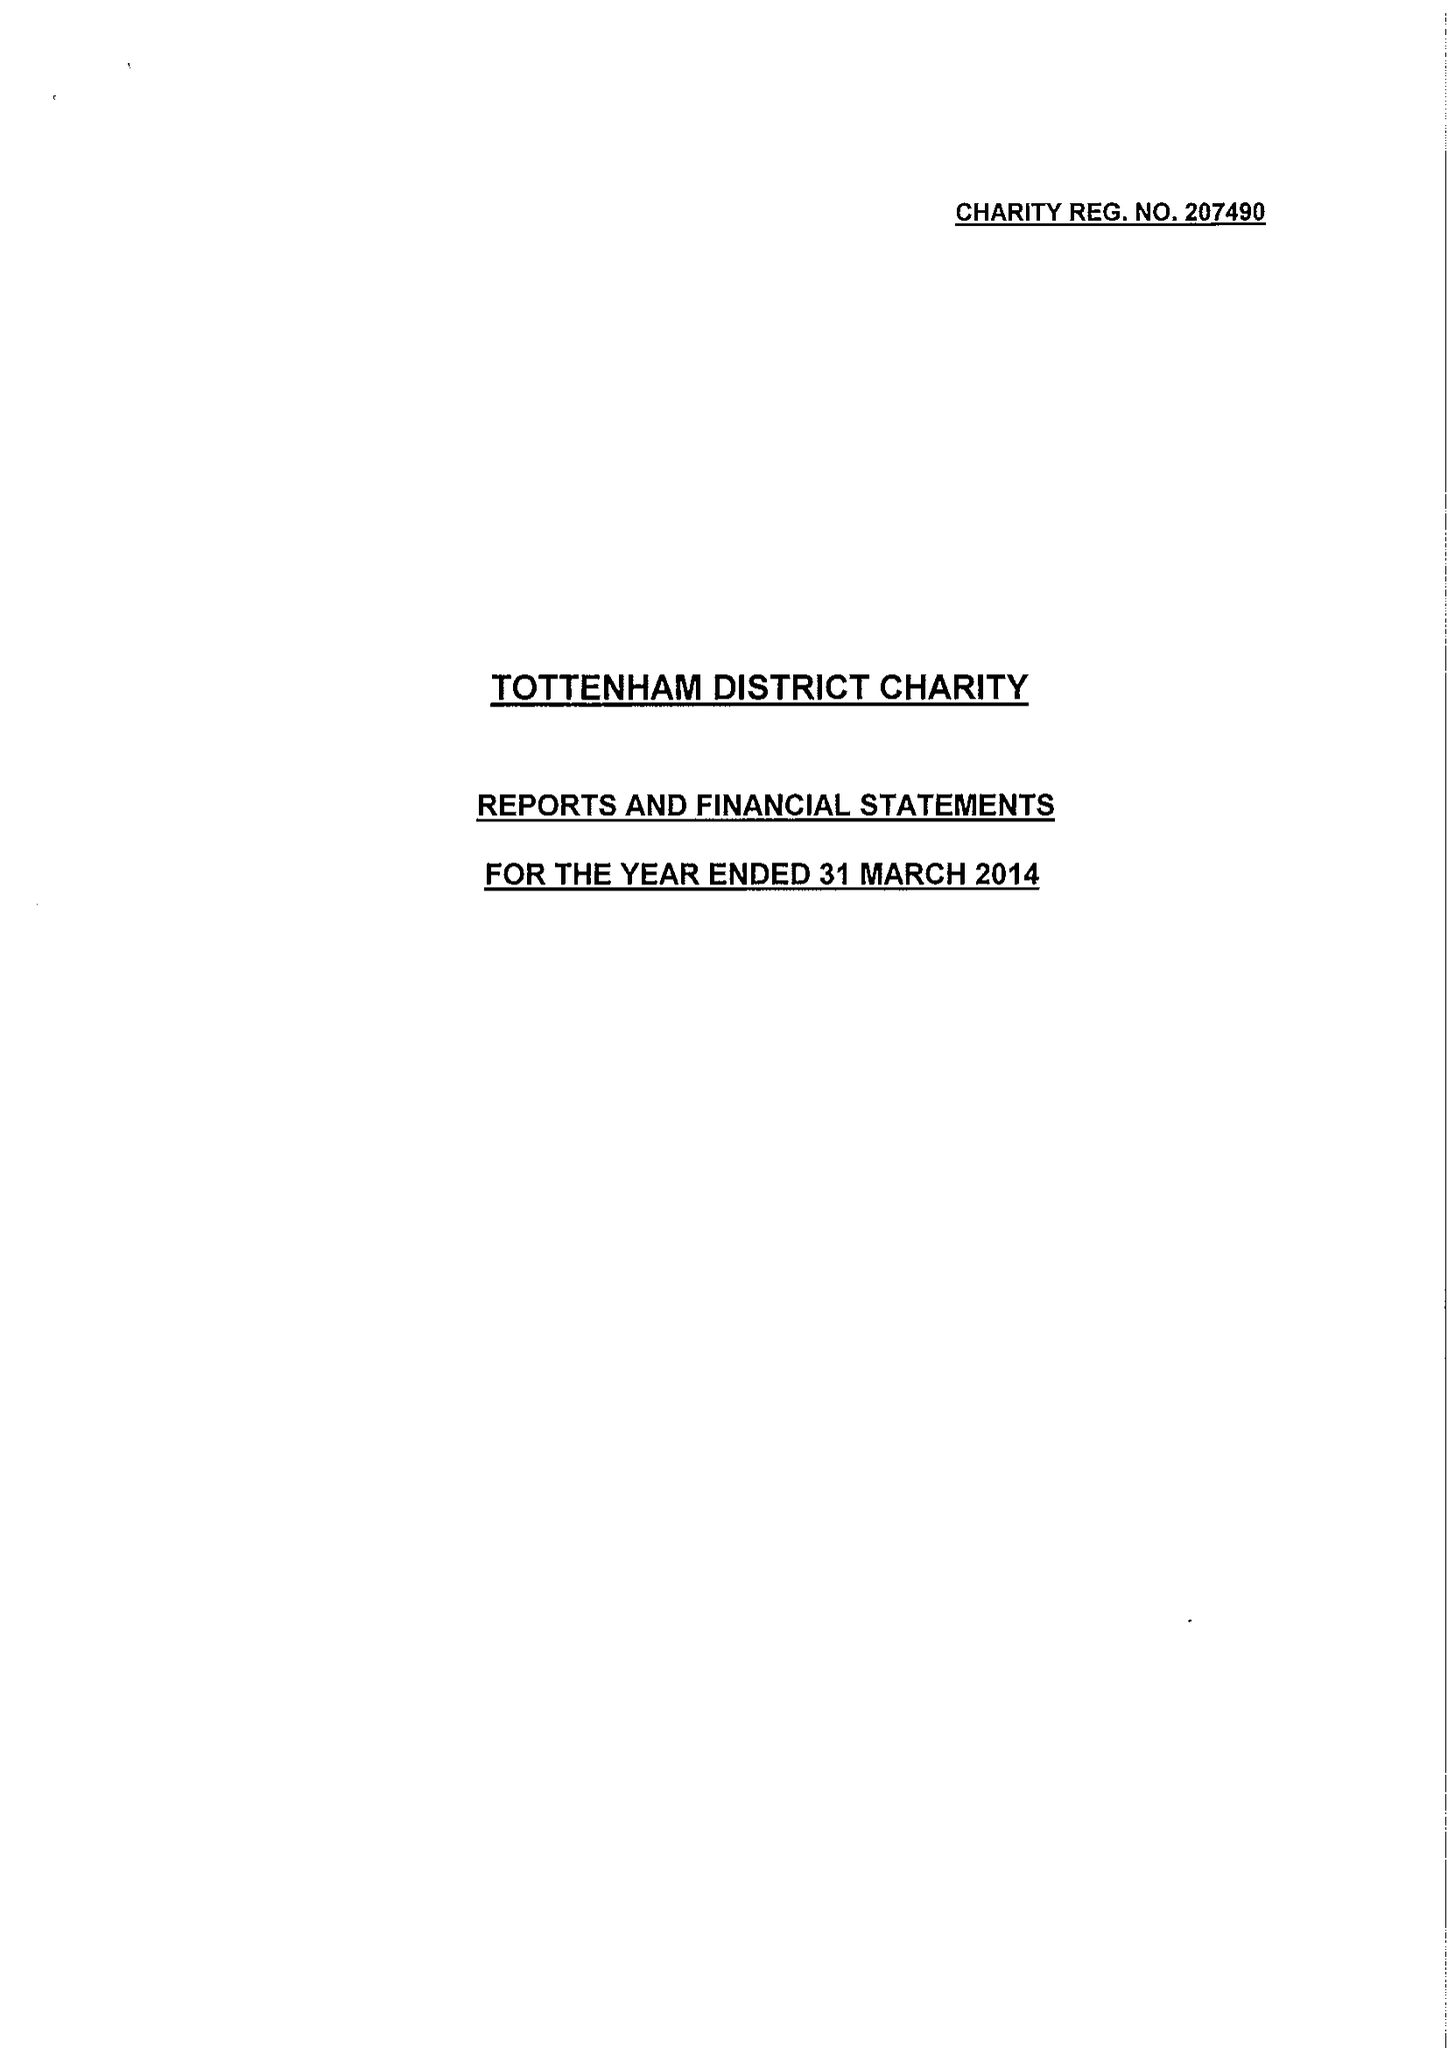What is the value for the address__street_line?
Answer the question using a single word or phrase. 225 HIGH ROAD 